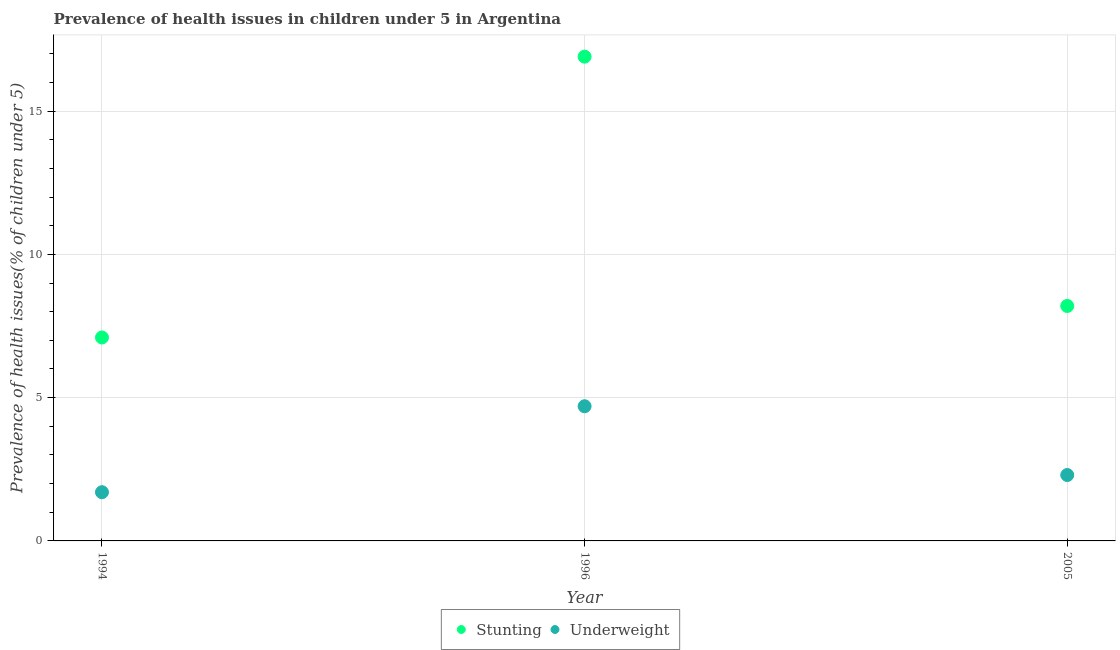How many different coloured dotlines are there?
Provide a short and direct response. 2. Is the number of dotlines equal to the number of legend labels?
Your response must be concise. Yes. What is the percentage of underweight children in 1994?
Offer a very short reply. 1.7. Across all years, what is the maximum percentage of stunted children?
Provide a succinct answer. 16.9. Across all years, what is the minimum percentage of stunted children?
Keep it short and to the point. 7.1. In which year was the percentage of stunted children maximum?
Make the answer very short. 1996. In which year was the percentage of stunted children minimum?
Ensure brevity in your answer.  1994. What is the total percentage of underweight children in the graph?
Your response must be concise. 8.7. What is the difference between the percentage of underweight children in 1996 and that in 2005?
Keep it short and to the point. 2.4. What is the difference between the percentage of underweight children in 1996 and the percentage of stunted children in 2005?
Offer a very short reply. -3.5. What is the average percentage of stunted children per year?
Offer a terse response. 10.73. In the year 1994, what is the difference between the percentage of stunted children and percentage of underweight children?
Offer a terse response. 5.4. In how many years, is the percentage of underweight children greater than 1 %?
Give a very brief answer. 3. What is the ratio of the percentage of stunted children in 1994 to that in 2005?
Your response must be concise. 0.87. Is the percentage of underweight children in 1994 less than that in 2005?
Your answer should be compact. Yes. What is the difference between the highest and the second highest percentage of underweight children?
Ensure brevity in your answer.  2.4. What is the difference between the highest and the lowest percentage of underweight children?
Keep it short and to the point. 3. How many dotlines are there?
Provide a succinct answer. 2. Where does the legend appear in the graph?
Provide a short and direct response. Bottom center. How many legend labels are there?
Your answer should be compact. 2. How are the legend labels stacked?
Your answer should be very brief. Horizontal. What is the title of the graph?
Offer a very short reply. Prevalence of health issues in children under 5 in Argentina. Does "Stunting" appear as one of the legend labels in the graph?
Your answer should be compact. Yes. What is the label or title of the X-axis?
Provide a succinct answer. Year. What is the label or title of the Y-axis?
Keep it short and to the point. Prevalence of health issues(% of children under 5). What is the Prevalence of health issues(% of children under 5) of Stunting in 1994?
Offer a very short reply. 7.1. What is the Prevalence of health issues(% of children under 5) of Underweight in 1994?
Give a very brief answer. 1.7. What is the Prevalence of health issues(% of children under 5) in Stunting in 1996?
Offer a very short reply. 16.9. What is the Prevalence of health issues(% of children under 5) of Underweight in 1996?
Provide a succinct answer. 4.7. What is the Prevalence of health issues(% of children under 5) of Stunting in 2005?
Offer a terse response. 8.2. What is the Prevalence of health issues(% of children under 5) in Underweight in 2005?
Ensure brevity in your answer.  2.3. Across all years, what is the maximum Prevalence of health issues(% of children under 5) of Stunting?
Your answer should be very brief. 16.9. Across all years, what is the maximum Prevalence of health issues(% of children under 5) in Underweight?
Offer a very short reply. 4.7. Across all years, what is the minimum Prevalence of health issues(% of children under 5) in Stunting?
Keep it short and to the point. 7.1. Across all years, what is the minimum Prevalence of health issues(% of children under 5) in Underweight?
Make the answer very short. 1.7. What is the total Prevalence of health issues(% of children under 5) in Stunting in the graph?
Provide a short and direct response. 32.2. What is the difference between the Prevalence of health issues(% of children under 5) of Stunting in 1994 and that in 2005?
Provide a succinct answer. -1.1. What is the difference between the Prevalence of health issues(% of children under 5) of Underweight in 1994 and that in 2005?
Make the answer very short. -0.6. What is the difference between the Prevalence of health issues(% of children under 5) of Underweight in 1996 and that in 2005?
Provide a short and direct response. 2.4. What is the difference between the Prevalence of health issues(% of children under 5) in Stunting in 1994 and the Prevalence of health issues(% of children under 5) in Underweight in 2005?
Keep it short and to the point. 4.8. What is the difference between the Prevalence of health issues(% of children under 5) of Stunting in 1996 and the Prevalence of health issues(% of children under 5) of Underweight in 2005?
Provide a short and direct response. 14.6. What is the average Prevalence of health issues(% of children under 5) in Stunting per year?
Offer a very short reply. 10.73. What is the average Prevalence of health issues(% of children under 5) of Underweight per year?
Provide a short and direct response. 2.9. In the year 1996, what is the difference between the Prevalence of health issues(% of children under 5) in Stunting and Prevalence of health issues(% of children under 5) in Underweight?
Your answer should be compact. 12.2. What is the ratio of the Prevalence of health issues(% of children under 5) of Stunting in 1994 to that in 1996?
Give a very brief answer. 0.42. What is the ratio of the Prevalence of health issues(% of children under 5) of Underweight in 1994 to that in 1996?
Give a very brief answer. 0.36. What is the ratio of the Prevalence of health issues(% of children under 5) in Stunting in 1994 to that in 2005?
Your answer should be compact. 0.87. What is the ratio of the Prevalence of health issues(% of children under 5) of Underweight in 1994 to that in 2005?
Give a very brief answer. 0.74. What is the ratio of the Prevalence of health issues(% of children under 5) in Stunting in 1996 to that in 2005?
Your answer should be compact. 2.06. What is the ratio of the Prevalence of health issues(% of children under 5) of Underweight in 1996 to that in 2005?
Offer a very short reply. 2.04. What is the difference between the highest and the second highest Prevalence of health issues(% of children under 5) of Stunting?
Give a very brief answer. 8.7. 